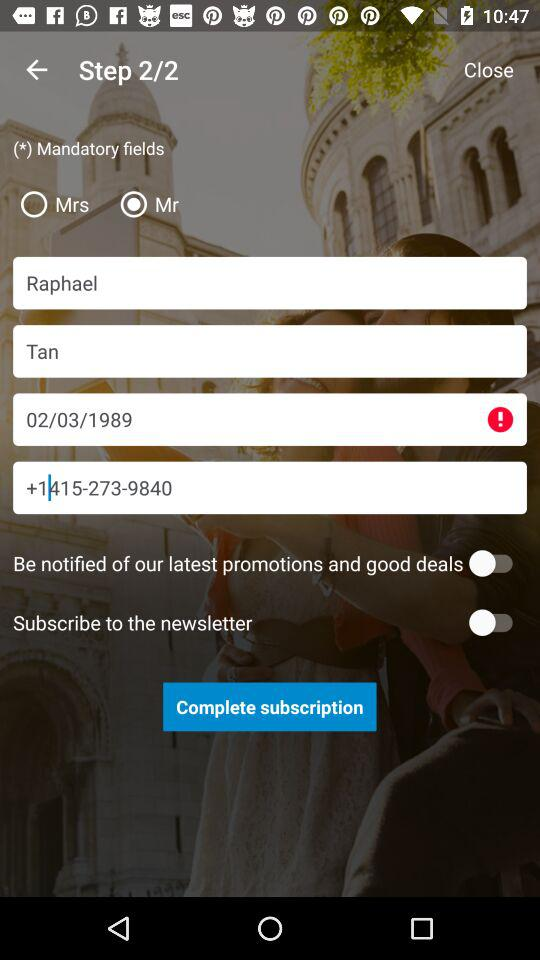What is the status of Mrs?
When the provided information is insufficient, respond with <no answer>. <no answer> 